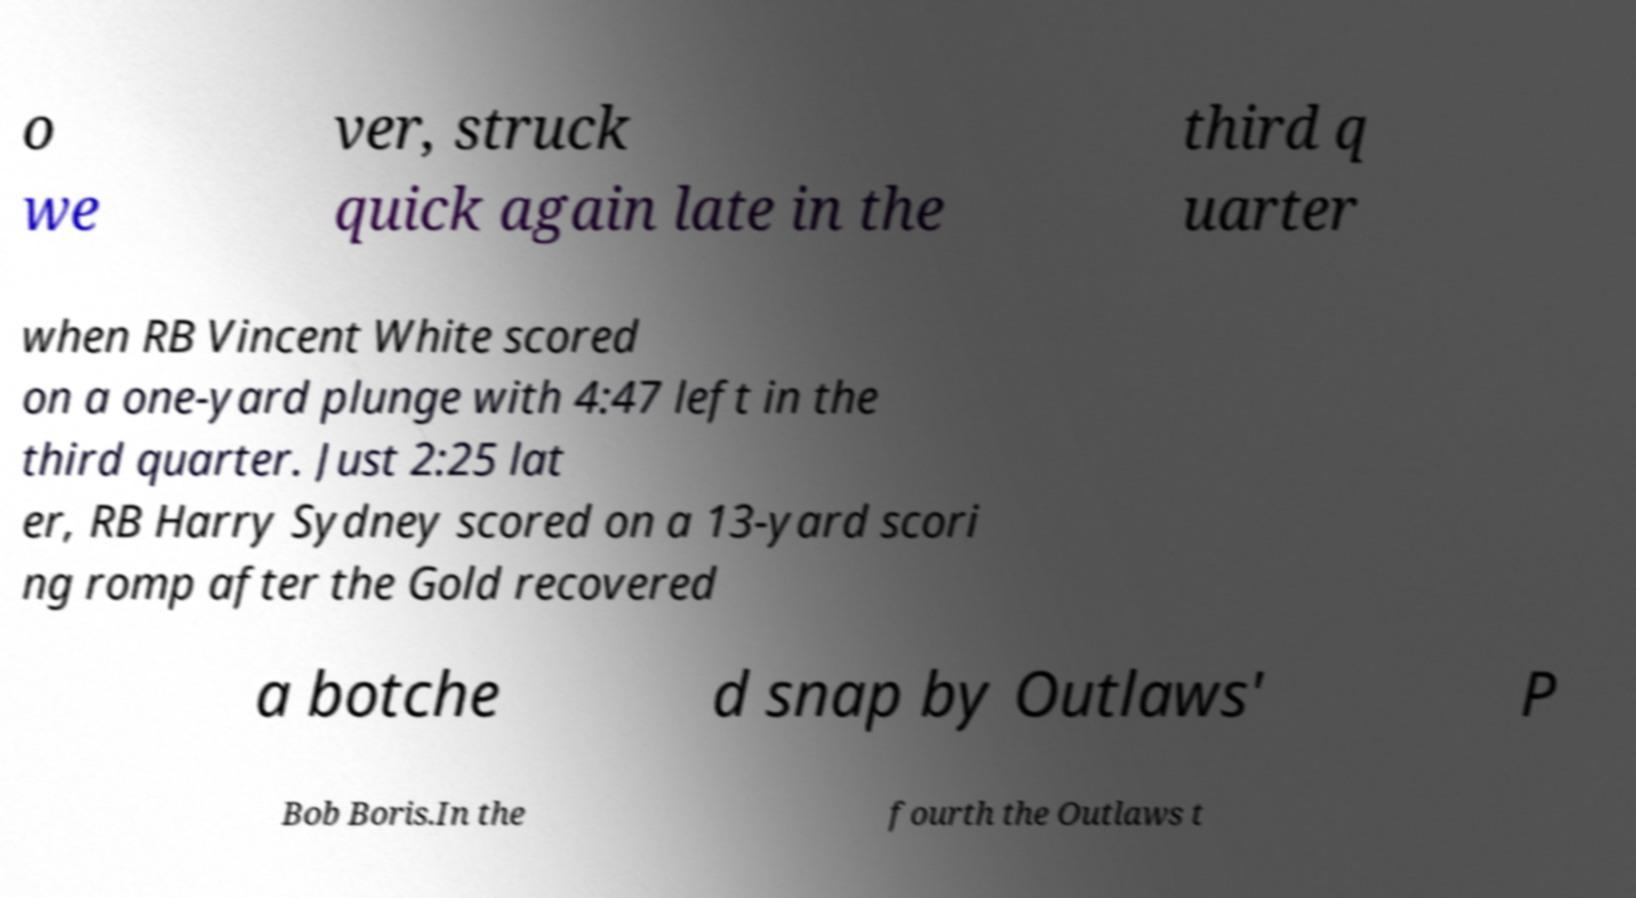Can you read and provide the text displayed in the image?This photo seems to have some interesting text. Can you extract and type it out for me? o we ver, struck quick again late in the third q uarter when RB Vincent White scored on a one-yard plunge with 4:47 left in the third quarter. Just 2:25 lat er, RB Harry Sydney scored on a 13-yard scori ng romp after the Gold recovered a botche d snap by Outlaws' P Bob Boris.In the fourth the Outlaws t 